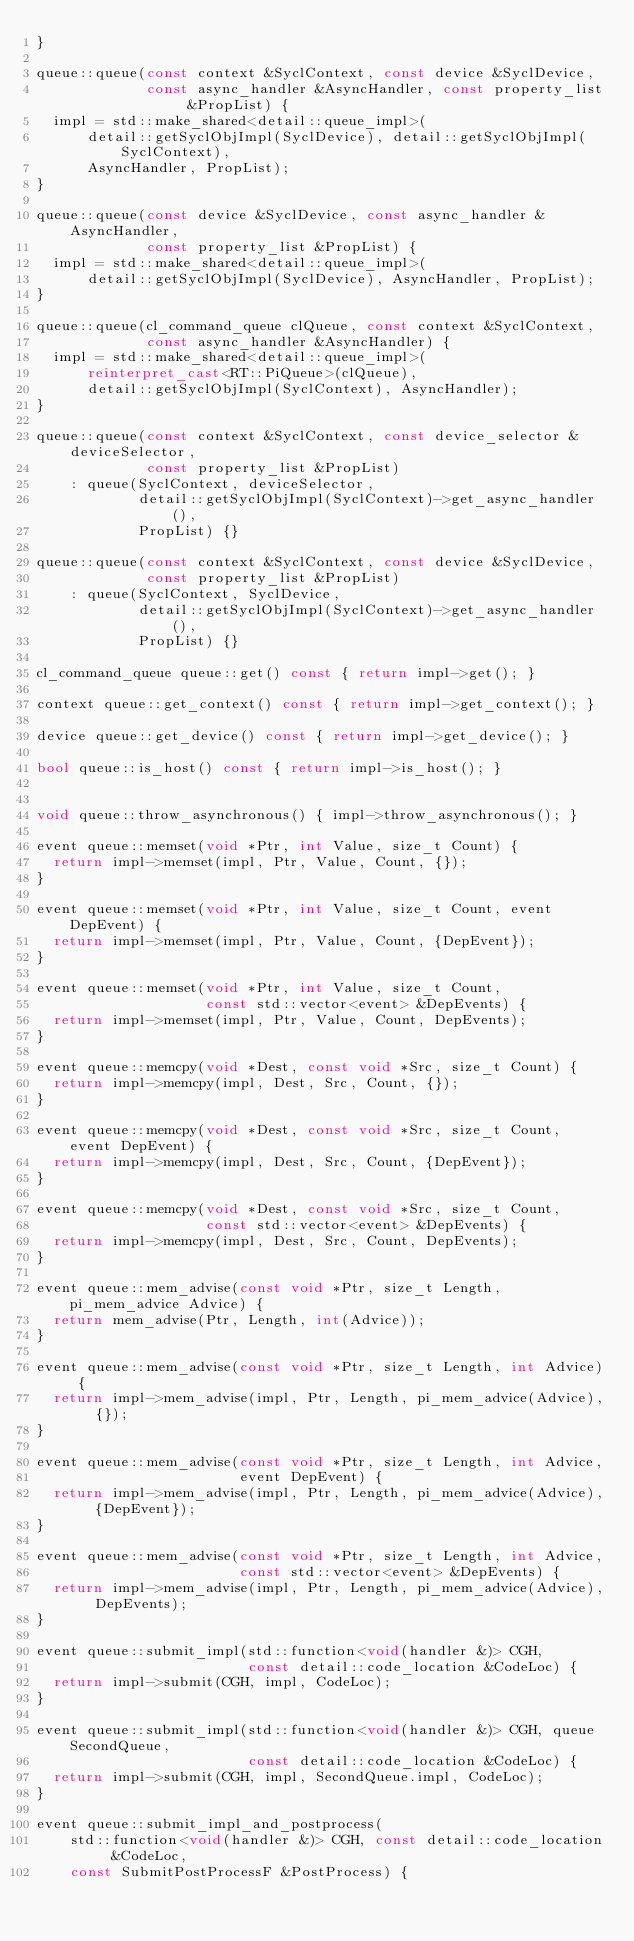<code> <loc_0><loc_0><loc_500><loc_500><_C++_>}

queue::queue(const context &SyclContext, const device &SyclDevice,
             const async_handler &AsyncHandler, const property_list &PropList) {
  impl = std::make_shared<detail::queue_impl>(
      detail::getSyclObjImpl(SyclDevice), detail::getSyclObjImpl(SyclContext),
      AsyncHandler, PropList);
}

queue::queue(const device &SyclDevice, const async_handler &AsyncHandler,
             const property_list &PropList) {
  impl = std::make_shared<detail::queue_impl>(
      detail::getSyclObjImpl(SyclDevice), AsyncHandler, PropList);
}

queue::queue(cl_command_queue clQueue, const context &SyclContext,
             const async_handler &AsyncHandler) {
  impl = std::make_shared<detail::queue_impl>(
      reinterpret_cast<RT::PiQueue>(clQueue),
      detail::getSyclObjImpl(SyclContext), AsyncHandler);
}

queue::queue(const context &SyclContext, const device_selector &deviceSelector,
             const property_list &PropList)
    : queue(SyclContext, deviceSelector,
            detail::getSyclObjImpl(SyclContext)->get_async_handler(),
            PropList) {}

queue::queue(const context &SyclContext, const device &SyclDevice,
             const property_list &PropList)
    : queue(SyclContext, SyclDevice,
            detail::getSyclObjImpl(SyclContext)->get_async_handler(),
            PropList) {}

cl_command_queue queue::get() const { return impl->get(); }

context queue::get_context() const { return impl->get_context(); }

device queue::get_device() const { return impl->get_device(); }

bool queue::is_host() const { return impl->is_host(); }


void queue::throw_asynchronous() { impl->throw_asynchronous(); }

event queue::memset(void *Ptr, int Value, size_t Count) {
  return impl->memset(impl, Ptr, Value, Count, {});
}

event queue::memset(void *Ptr, int Value, size_t Count, event DepEvent) {
  return impl->memset(impl, Ptr, Value, Count, {DepEvent});
}

event queue::memset(void *Ptr, int Value, size_t Count,
                    const std::vector<event> &DepEvents) {
  return impl->memset(impl, Ptr, Value, Count, DepEvents);
}

event queue::memcpy(void *Dest, const void *Src, size_t Count) {
  return impl->memcpy(impl, Dest, Src, Count, {});
}

event queue::memcpy(void *Dest, const void *Src, size_t Count, event DepEvent) {
  return impl->memcpy(impl, Dest, Src, Count, {DepEvent});
}

event queue::memcpy(void *Dest, const void *Src, size_t Count,
                    const std::vector<event> &DepEvents) {
  return impl->memcpy(impl, Dest, Src, Count, DepEvents);
}

event queue::mem_advise(const void *Ptr, size_t Length, pi_mem_advice Advice) {
  return mem_advise(Ptr, Length, int(Advice));
}

event queue::mem_advise(const void *Ptr, size_t Length, int Advice) {
  return impl->mem_advise(impl, Ptr, Length, pi_mem_advice(Advice), {});
}

event queue::mem_advise(const void *Ptr, size_t Length, int Advice,
                        event DepEvent) {
  return impl->mem_advise(impl, Ptr, Length, pi_mem_advice(Advice), {DepEvent});
}

event queue::mem_advise(const void *Ptr, size_t Length, int Advice,
                        const std::vector<event> &DepEvents) {
  return impl->mem_advise(impl, Ptr, Length, pi_mem_advice(Advice), DepEvents);
}

event queue::submit_impl(std::function<void(handler &)> CGH,
                         const detail::code_location &CodeLoc) {
  return impl->submit(CGH, impl, CodeLoc);
}

event queue::submit_impl(std::function<void(handler &)> CGH, queue SecondQueue,
                         const detail::code_location &CodeLoc) {
  return impl->submit(CGH, impl, SecondQueue.impl, CodeLoc);
}

event queue::submit_impl_and_postprocess(
    std::function<void(handler &)> CGH, const detail::code_location &CodeLoc,
    const SubmitPostProcessF &PostProcess) {</code> 